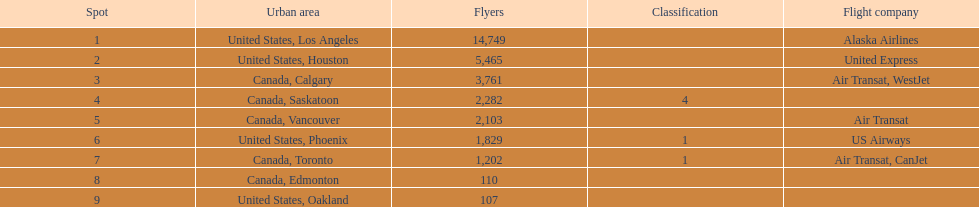What is the typical count of passengers in the united states? 5537.5. 